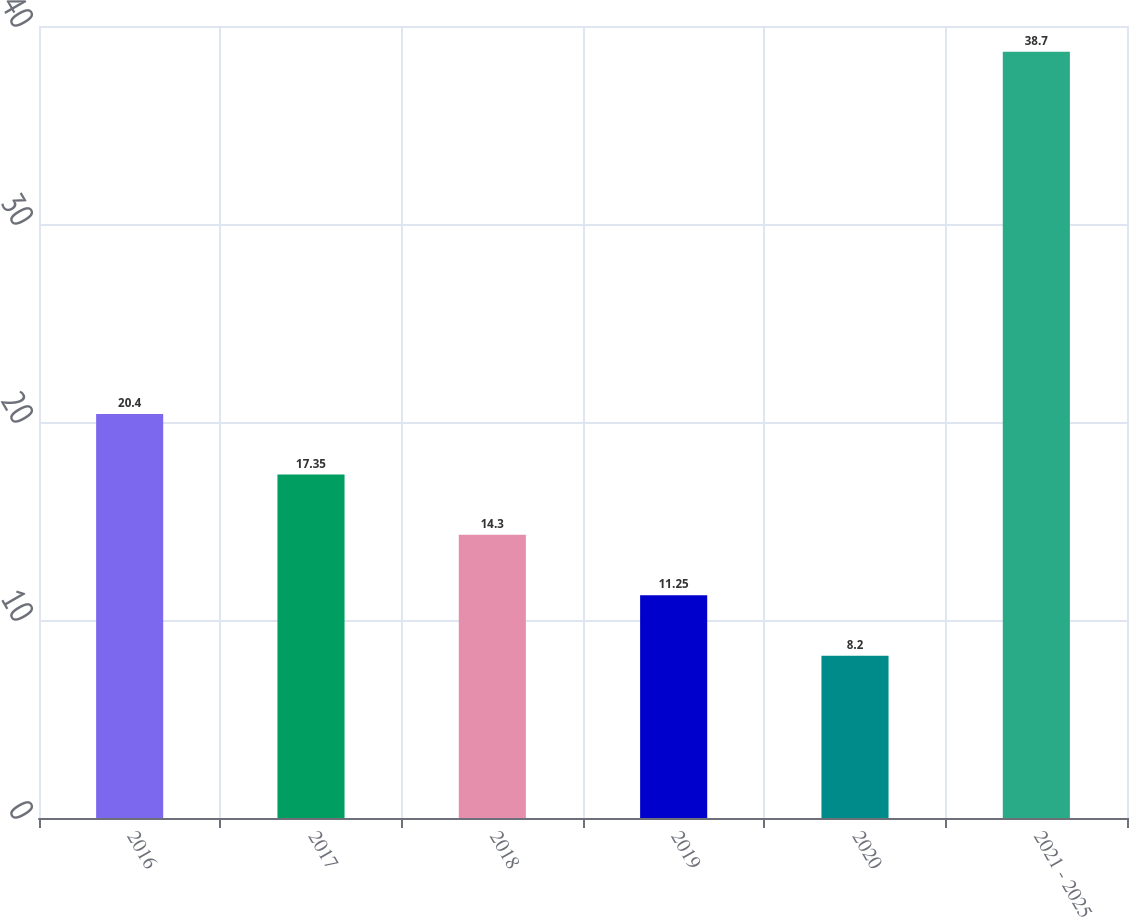Convert chart to OTSL. <chart><loc_0><loc_0><loc_500><loc_500><bar_chart><fcel>2016<fcel>2017<fcel>2018<fcel>2019<fcel>2020<fcel>2021 - 2025<nl><fcel>20.4<fcel>17.35<fcel>14.3<fcel>11.25<fcel>8.2<fcel>38.7<nl></chart> 